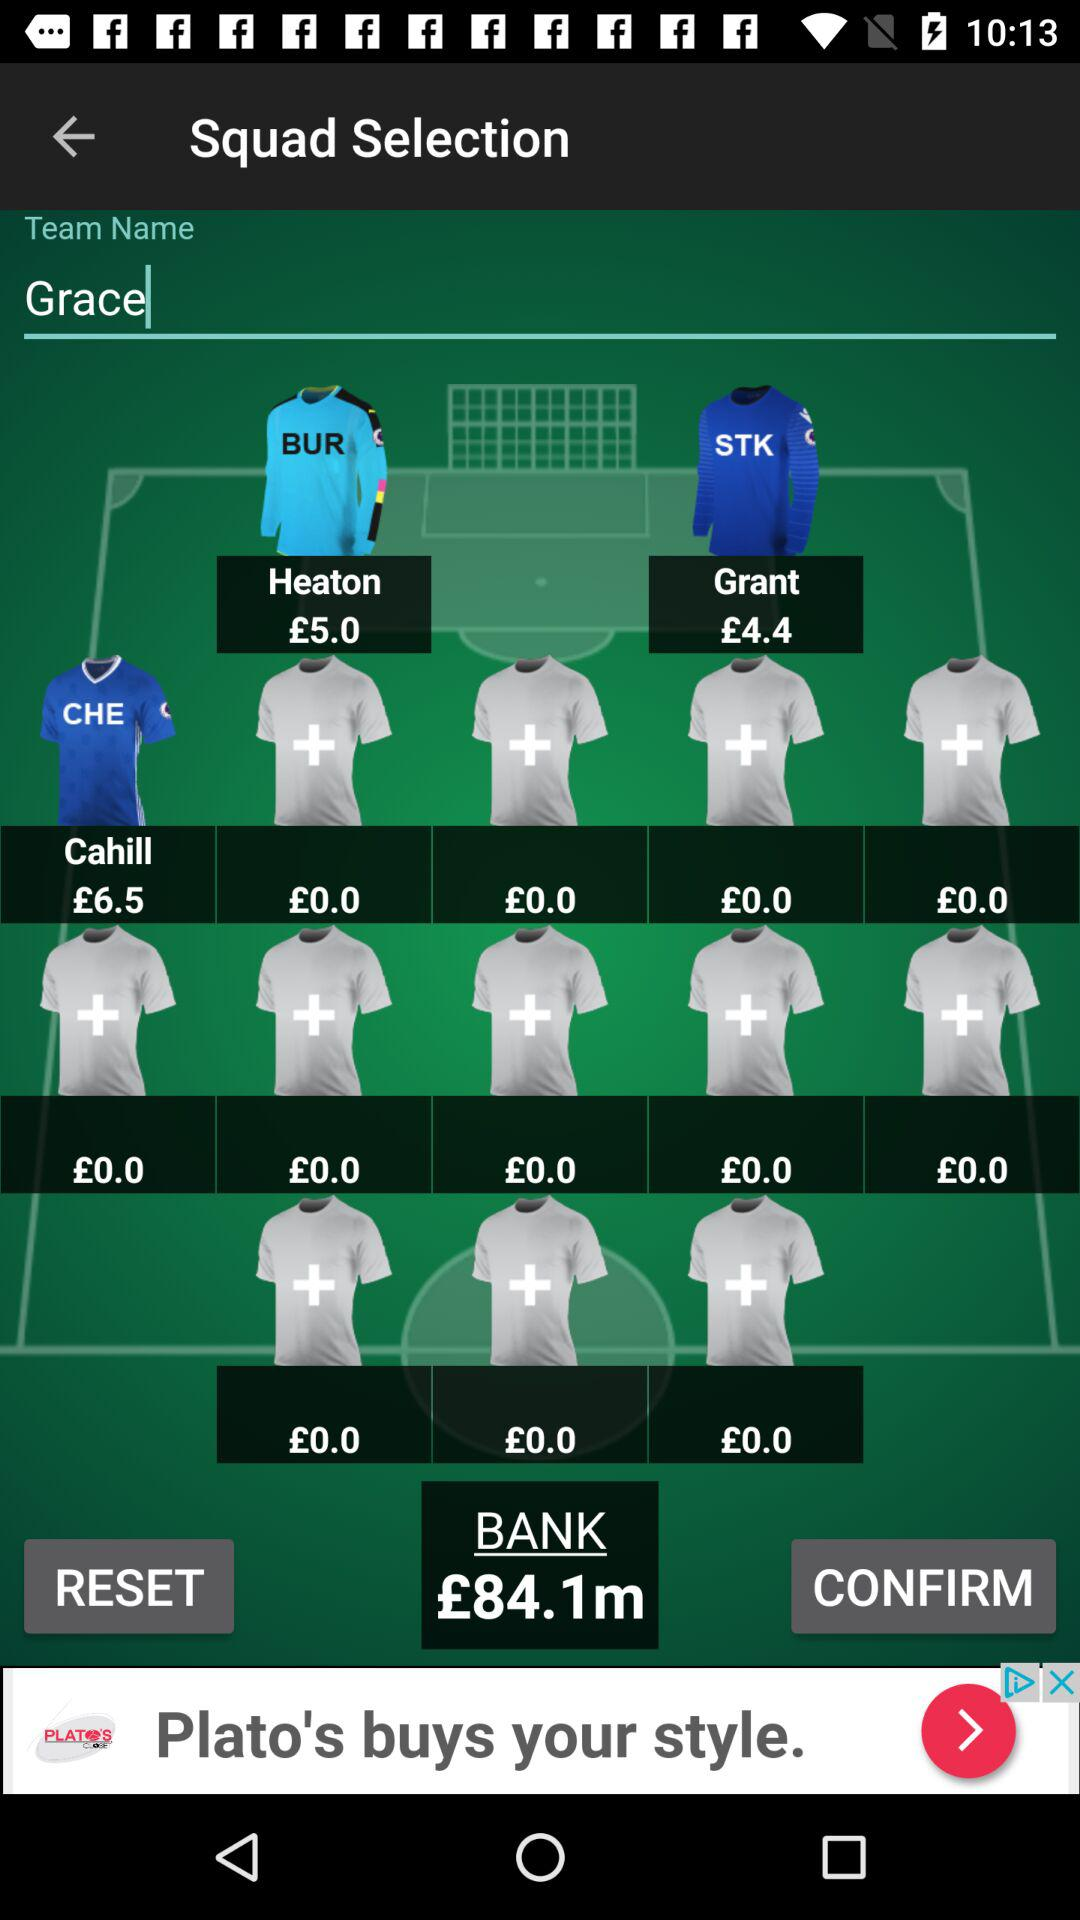What's the total count of bank? The total count is £84.1m. 